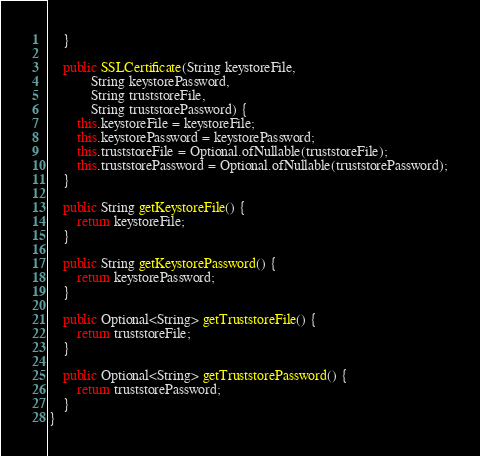<code> <loc_0><loc_0><loc_500><loc_500><_Java_>    }

    public SSLCertificate(String keystoreFile,
            String keystorePassword,
            String truststoreFile,
            String truststorePassword) {
        this.keystoreFile = keystoreFile;
        this.keystorePassword = keystorePassword;
        this.truststoreFile = Optional.ofNullable(truststoreFile);
        this.truststorePassword = Optional.ofNullable(truststorePassword);
    }

    public String getKeystoreFile() {
        return keystoreFile;
    }

    public String getKeystorePassword() {
        return keystorePassword;
    }

    public Optional<String> getTruststoreFile() {
        return truststoreFile;
    }

    public Optional<String> getTruststorePassword() {
        return truststorePassword;
    }
}
</code> 